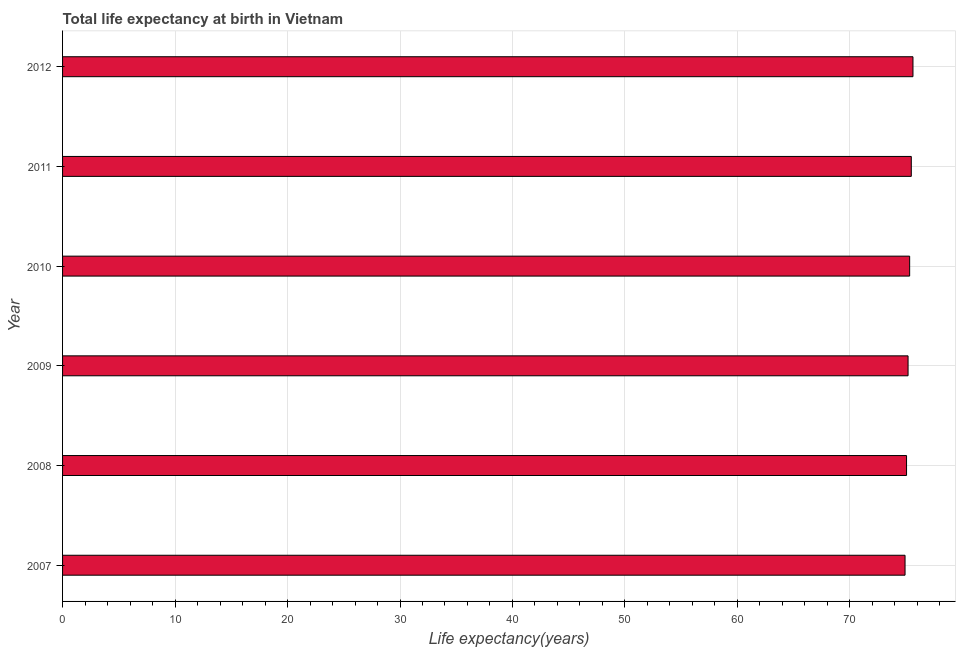What is the title of the graph?
Your answer should be very brief. Total life expectancy at birth in Vietnam. What is the label or title of the X-axis?
Offer a terse response. Life expectancy(years). What is the life expectancy at birth in 2011?
Provide a succinct answer. 75.46. Across all years, what is the maximum life expectancy at birth?
Make the answer very short. 75.61. Across all years, what is the minimum life expectancy at birth?
Ensure brevity in your answer.  74.9. In which year was the life expectancy at birth maximum?
Provide a succinct answer. 2012. In which year was the life expectancy at birth minimum?
Keep it short and to the point. 2007. What is the sum of the life expectancy at birth?
Provide a short and direct response. 451.48. What is the difference between the life expectancy at birth in 2007 and 2012?
Give a very brief answer. -0.7. What is the average life expectancy at birth per year?
Offer a terse response. 75.25. What is the median life expectancy at birth?
Offer a terse response. 75.24. What is the ratio of the life expectancy at birth in 2007 to that in 2011?
Your answer should be very brief. 0.99. Is the life expectancy at birth in 2007 less than that in 2011?
Offer a very short reply. Yes. Is the difference between the life expectancy at birth in 2008 and 2010 greater than the difference between any two years?
Ensure brevity in your answer.  No. What is the difference between the highest and the second highest life expectancy at birth?
Make the answer very short. 0.15. What is the difference between the highest and the lowest life expectancy at birth?
Make the answer very short. 0.7. How many years are there in the graph?
Offer a very short reply. 6. What is the difference between two consecutive major ticks on the X-axis?
Provide a short and direct response. 10. What is the Life expectancy(years) in 2007?
Offer a terse response. 74.9. What is the Life expectancy(years) of 2008?
Provide a short and direct response. 75.04. What is the Life expectancy(years) of 2009?
Ensure brevity in your answer.  75.17. What is the Life expectancy(years) in 2010?
Offer a terse response. 75.31. What is the Life expectancy(years) in 2011?
Ensure brevity in your answer.  75.46. What is the Life expectancy(years) of 2012?
Keep it short and to the point. 75.61. What is the difference between the Life expectancy(years) in 2007 and 2008?
Your response must be concise. -0.13. What is the difference between the Life expectancy(years) in 2007 and 2009?
Ensure brevity in your answer.  -0.27. What is the difference between the Life expectancy(years) in 2007 and 2010?
Offer a terse response. -0.41. What is the difference between the Life expectancy(years) in 2007 and 2011?
Offer a very short reply. -0.56. What is the difference between the Life expectancy(years) in 2007 and 2012?
Your response must be concise. -0.7. What is the difference between the Life expectancy(years) in 2008 and 2009?
Your response must be concise. -0.14. What is the difference between the Life expectancy(years) in 2008 and 2010?
Your answer should be compact. -0.28. What is the difference between the Life expectancy(years) in 2008 and 2011?
Your answer should be very brief. -0.42. What is the difference between the Life expectancy(years) in 2008 and 2012?
Make the answer very short. -0.57. What is the difference between the Life expectancy(years) in 2009 and 2010?
Make the answer very short. -0.14. What is the difference between the Life expectancy(years) in 2009 and 2011?
Keep it short and to the point. -0.29. What is the difference between the Life expectancy(years) in 2009 and 2012?
Ensure brevity in your answer.  -0.44. What is the difference between the Life expectancy(years) in 2010 and 2011?
Your response must be concise. -0.15. What is the difference between the Life expectancy(years) in 2010 and 2012?
Provide a succinct answer. -0.29. What is the difference between the Life expectancy(years) in 2011 and 2012?
Offer a very short reply. -0.15. What is the ratio of the Life expectancy(years) in 2007 to that in 2008?
Give a very brief answer. 1. What is the ratio of the Life expectancy(years) in 2007 to that in 2012?
Your answer should be compact. 0.99. What is the ratio of the Life expectancy(years) in 2008 to that in 2010?
Your answer should be very brief. 1. What is the ratio of the Life expectancy(years) in 2009 to that in 2011?
Your response must be concise. 1. What is the ratio of the Life expectancy(years) in 2010 to that in 2011?
Your answer should be very brief. 1. What is the ratio of the Life expectancy(years) in 2010 to that in 2012?
Your answer should be very brief. 1. 